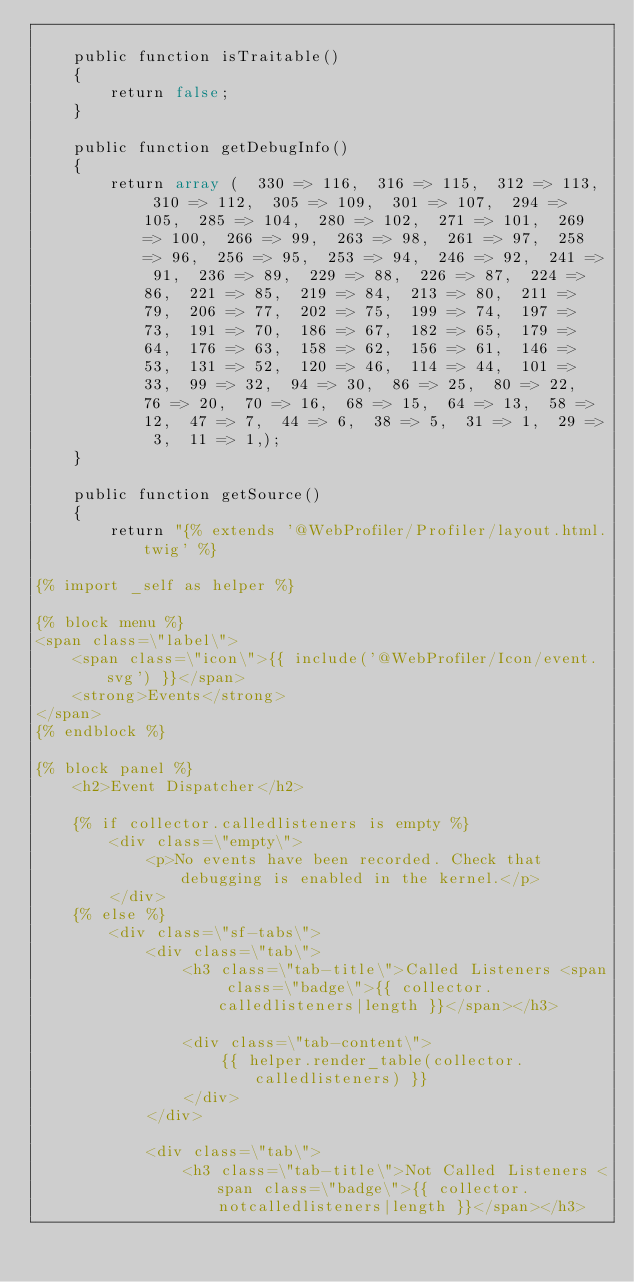<code> <loc_0><loc_0><loc_500><loc_500><_PHP_>
    public function isTraitable()
    {
        return false;
    }

    public function getDebugInfo()
    {
        return array (  330 => 116,  316 => 115,  312 => 113,  310 => 112,  305 => 109,  301 => 107,  294 => 105,  285 => 104,  280 => 102,  271 => 101,  269 => 100,  266 => 99,  263 => 98,  261 => 97,  258 => 96,  256 => 95,  253 => 94,  246 => 92,  241 => 91,  236 => 89,  229 => 88,  226 => 87,  224 => 86,  221 => 85,  219 => 84,  213 => 80,  211 => 79,  206 => 77,  202 => 75,  199 => 74,  197 => 73,  191 => 70,  186 => 67,  182 => 65,  179 => 64,  176 => 63,  158 => 62,  156 => 61,  146 => 53,  131 => 52,  120 => 46,  114 => 44,  101 => 33,  99 => 32,  94 => 30,  86 => 25,  80 => 22,  76 => 20,  70 => 16,  68 => 15,  64 => 13,  58 => 12,  47 => 7,  44 => 6,  38 => 5,  31 => 1,  29 => 3,  11 => 1,);
    }

    public function getSource()
    {
        return "{% extends '@WebProfiler/Profiler/layout.html.twig' %}

{% import _self as helper %}

{% block menu %}
<span class=\"label\">
    <span class=\"icon\">{{ include('@WebProfiler/Icon/event.svg') }}</span>
    <strong>Events</strong>
</span>
{% endblock %}

{% block panel %}
    <h2>Event Dispatcher</h2>

    {% if collector.calledlisteners is empty %}
        <div class=\"empty\">
            <p>No events have been recorded. Check that debugging is enabled in the kernel.</p>
        </div>
    {% else %}
        <div class=\"sf-tabs\">
            <div class=\"tab\">
                <h3 class=\"tab-title\">Called Listeners <span class=\"badge\">{{ collector.calledlisteners|length }}</span></h3>

                <div class=\"tab-content\">
                    {{ helper.render_table(collector.calledlisteners) }}
                </div>
            </div>

            <div class=\"tab\">
                <h3 class=\"tab-title\">Not Called Listeners <span class=\"badge\">{{ collector.notcalledlisteners|length }}</span></h3></code> 